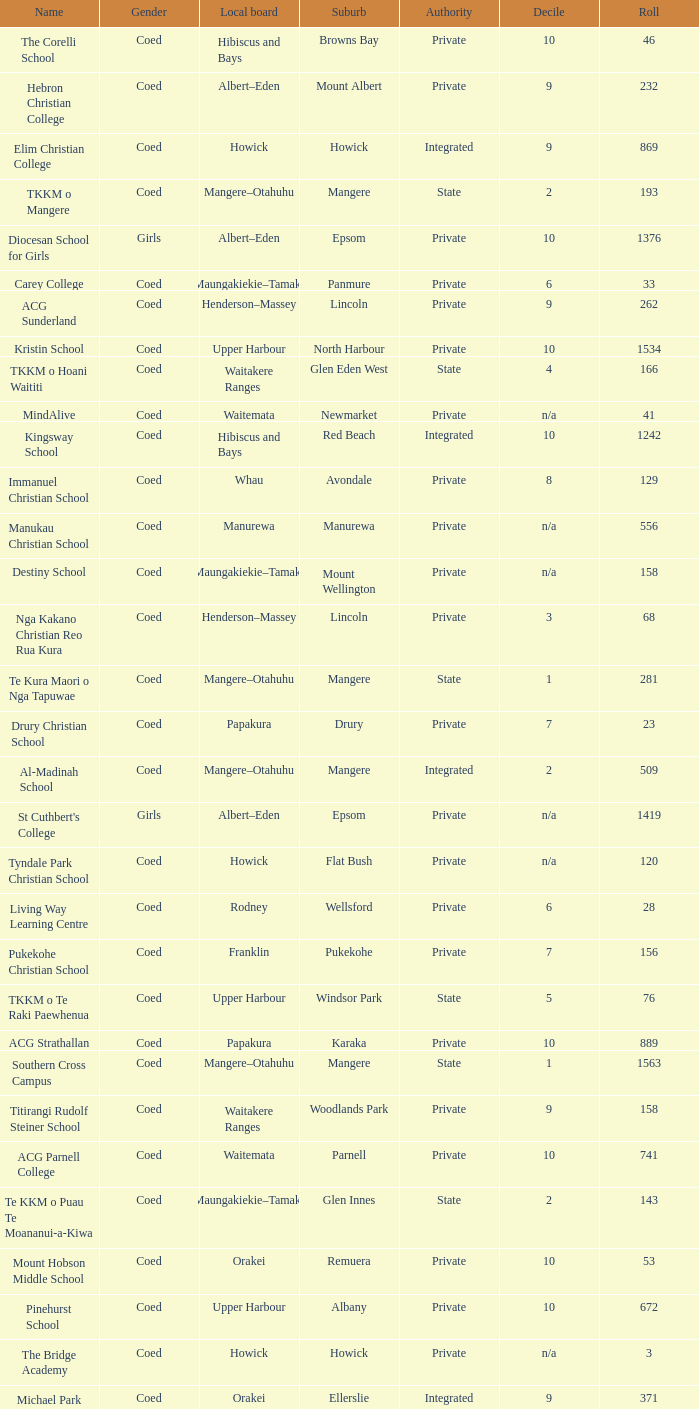What is the name when the local board is albert–eden, and a Decile of 9? Hebron Christian College. 